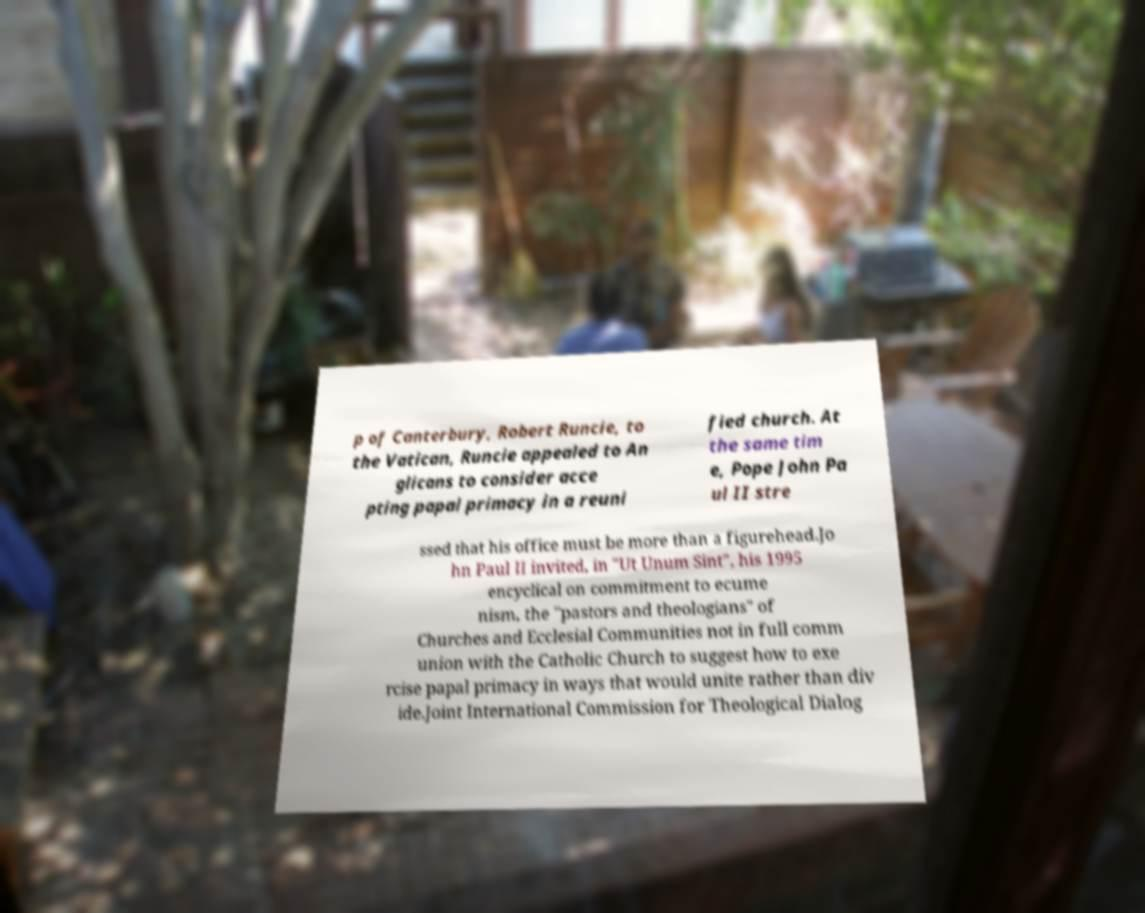Could you assist in decoding the text presented in this image and type it out clearly? p of Canterbury, Robert Runcie, to the Vatican, Runcie appealed to An glicans to consider acce pting papal primacy in a reuni fied church. At the same tim e, Pope John Pa ul II stre ssed that his office must be more than a figurehead.Jo hn Paul II invited, in "Ut Unum Sint", his 1995 encyclical on commitment to ecume nism, the "pastors and theologians" of Churches and Ecclesial Communities not in full comm union with the Catholic Church to suggest how to exe rcise papal primacy in ways that would unite rather than div ide.Joint International Commission for Theological Dialog 